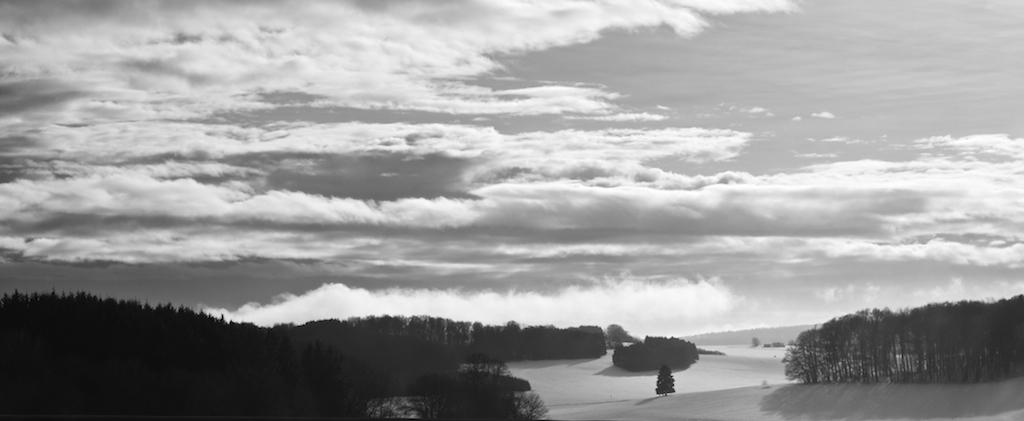Where was the picture taken? The picture was clicked outside the city. What can be seen in the foreground of the image? There are trees and the ground visible in the foreground of the image. What is visible in the background of the image? There is a sky in the background of the image. How would you describe the sky in the image? The sky is full of clouds. What is the tendency of the train in the image? There is no train present in the image, so it is not possible to determine its tendency. 